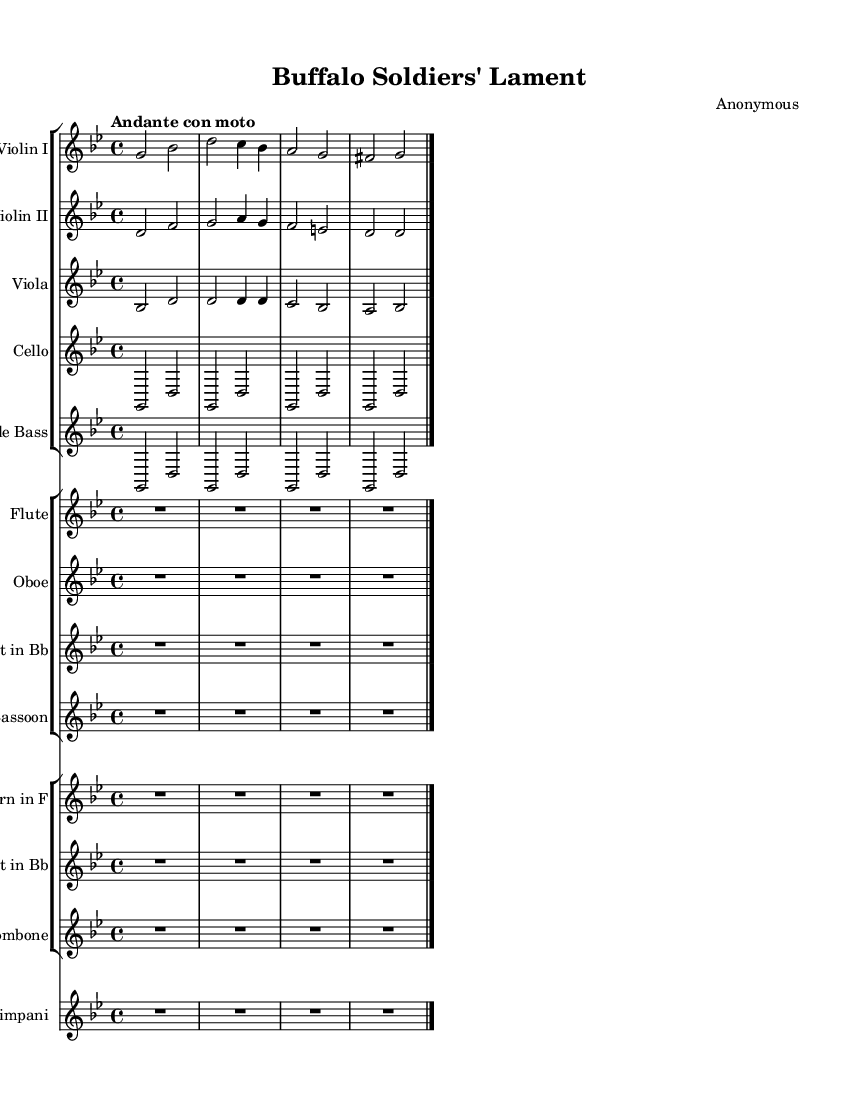What is the key signature of this music? The key signature is G minor, which has two flats (B♭ and E♭). This is indicated at the beginning of the staff with two flat symbols.
Answer: G minor What is the time signature of this piece? The time signature is 4/4, which is represented by the numbers placed at the beginning of the sheet music. This means there are four beats in each measure, and the quarter note gets one beat.
Answer: 4/4 What is the tempo marking of this composition? The tempo marking is "Andante con moto," which gives a tempo indication of a moderately slow pace with a bit of movement. This is often indicated in Italian at the beginning of the music.
Answer: Andante con moto How many instruments are featured in this piece? There are ten instruments indicated in the score. They include strings (violins, viola, cello, double bass), woodwinds (flute, oboe, clarinet, bassoon), brass (horn, trumpet, trombone), and timpani.
Answer: Ten instruments What is the structure of this symphony? The structure displays a layered orchestration, with distinct sections for strings, woodwinds, and brass, suggesting a resonant and rich symphonic texture characteristic of the Romantic era. This complexity defines the orchestral arrangements typical of the period.
Answer: Layered orchestration Which instrument has a rest for the entire measure in the beginning? The flute has a rest for the entire first measure, as indicated by the R symbol followed by the note duration, which indicates silence in that measure. This can point toward its role in later harmony or solo passages.
Answer: Flute 